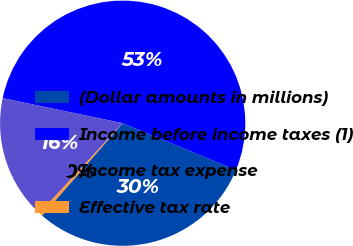Convert chart. <chart><loc_0><loc_0><loc_500><loc_500><pie_chart><fcel>(Dollar amounts in millions)<fcel>Income before income taxes (1)<fcel>Income tax expense<fcel>Effective tax rate<nl><fcel>30.17%<fcel>52.96%<fcel>16.4%<fcel>0.46%<nl></chart> 